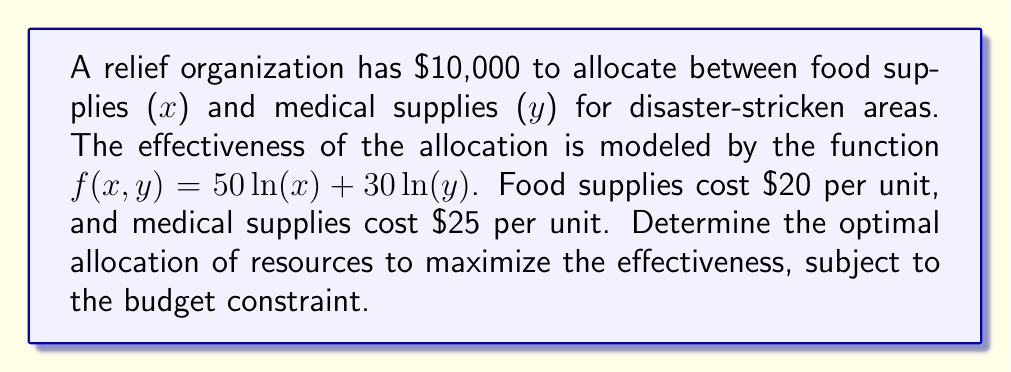Give your solution to this math problem. 1) First, we set up the constrained optimization problem:

   Maximize: $f(x,y) = 50\ln(x) + 30\ln(y)$
   Subject to: $20x + 25y = 10000$

2) We use the method of Lagrange multipliers. Let $\lambda$ be the Lagrange multiplier:

   $L(x,y,\lambda) = 50\ln(x) + 30\ln(y) - \lambda(20x + 25y - 10000)$

3) We take partial derivatives and set them to zero:

   $\frac{\partial L}{\partial x} = \frac{50}{x} - 20\lambda = 0$
   $\frac{\partial L}{\partial y} = \frac{30}{y} - 25\lambda = 0$
   $\frac{\partial L}{\partial \lambda} = 20x + 25y - 10000 = 0$

4) From the first two equations:

   $x = \frac{50}{20\lambda} = \frac{5}{2\lambda}$
   $y = \frac{30}{25\lambda} = \frac{6}{5\lambda}$

5) Substitute these into the constraint equation:

   $20(\frac{5}{2\lambda}) + 25(\frac{6}{5\lambda}) = 10000$

6) Simplify:

   $\frac{50}{\lambda} + \frac{30}{\lambda} = 10000$
   $\frac{80}{\lambda} = 10000$
   $\lambda = \frac{1}{125}$

7) Now we can find $x$ and $y$:

   $x = \frac{5}{2}(125) = 312.5$
   $y = \frac{6}{5}(125) = 150$

8) Since we can't have fractional units, we round down to ensure we stay within budget:

   $x = 312$ units of food supplies
   $y = 150$ units of medical supplies

9) Verify the budget constraint:

   $20(312) + 25(150) = 6240 + 3750 = 9990 \leq 10000$
Answer: 312 units of food supplies, 150 units of medical supplies 